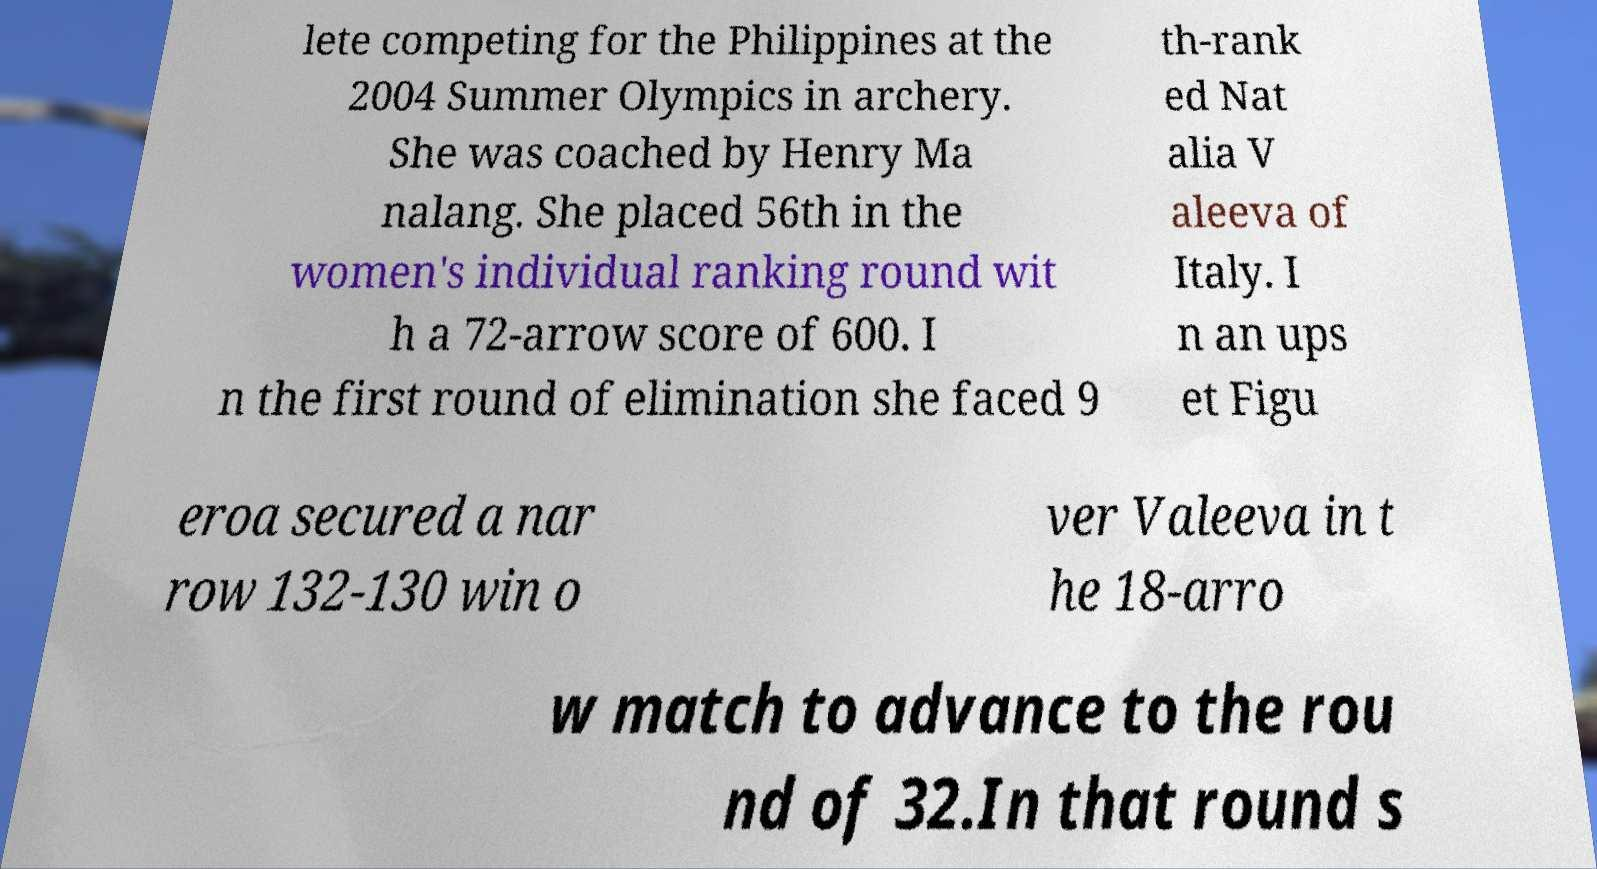For documentation purposes, I need the text within this image transcribed. Could you provide that? lete competing for the Philippines at the 2004 Summer Olympics in archery. She was coached by Henry Ma nalang. She placed 56th in the women's individual ranking round wit h a 72-arrow score of 600. I n the first round of elimination she faced 9 th-rank ed Nat alia V aleeva of Italy. I n an ups et Figu eroa secured a nar row 132-130 win o ver Valeeva in t he 18-arro w match to advance to the rou nd of 32.In that round s 